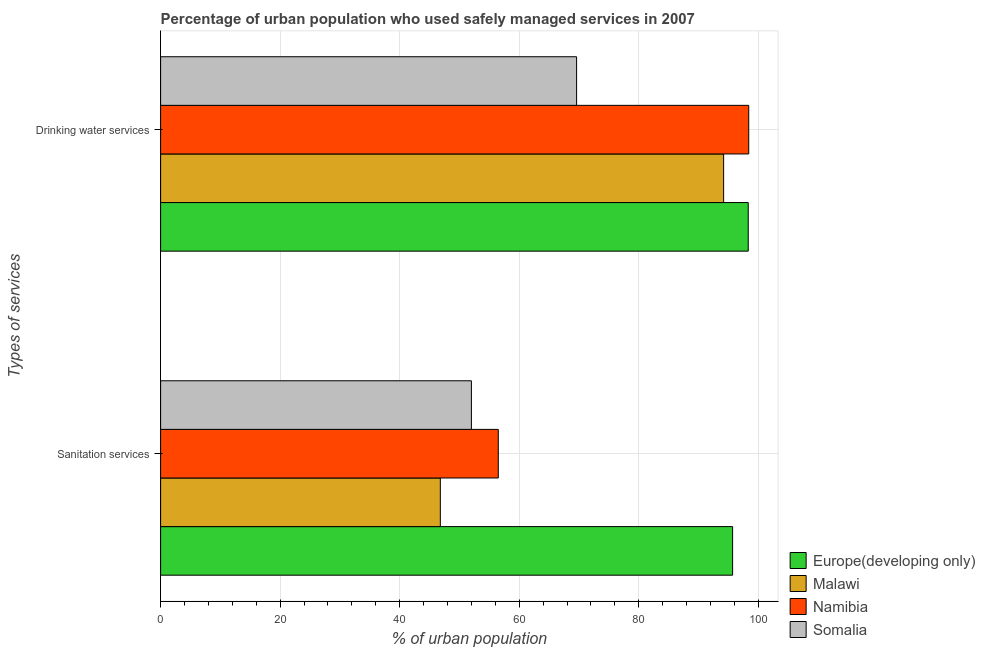How many different coloured bars are there?
Your answer should be compact. 4. How many groups of bars are there?
Offer a terse response. 2. Are the number of bars per tick equal to the number of legend labels?
Offer a very short reply. Yes. How many bars are there on the 2nd tick from the bottom?
Provide a short and direct response. 4. What is the label of the 2nd group of bars from the top?
Your answer should be compact. Sanitation services. What is the percentage of urban population who used drinking water services in Europe(developing only)?
Provide a succinct answer. 98.32. Across all countries, what is the maximum percentage of urban population who used sanitation services?
Ensure brevity in your answer.  95.7. Across all countries, what is the minimum percentage of urban population who used sanitation services?
Your answer should be very brief. 46.8. In which country was the percentage of urban population who used sanitation services maximum?
Give a very brief answer. Europe(developing only). In which country was the percentage of urban population who used drinking water services minimum?
Ensure brevity in your answer.  Somalia. What is the total percentage of urban population who used drinking water services in the graph?
Provide a short and direct response. 360.52. What is the difference between the percentage of urban population who used sanitation services in Namibia and that in Somalia?
Your answer should be very brief. 4.5. What is the difference between the percentage of urban population who used sanitation services in Europe(developing only) and the percentage of urban population who used drinking water services in Namibia?
Offer a very short reply. -2.7. What is the average percentage of urban population who used drinking water services per country?
Your response must be concise. 90.13. What is the difference between the percentage of urban population who used drinking water services and percentage of urban population who used sanitation services in Somalia?
Provide a succinct answer. 17.6. In how many countries, is the percentage of urban population who used drinking water services greater than 60 %?
Your answer should be very brief. 4. What is the ratio of the percentage of urban population who used drinking water services in Europe(developing only) to that in Somalia?
Keep it short and to the point. 1.41. In how many countries, is the percentage of urban population who used sanitation services greater than the average percentage of urban population who used sanitation services taken over all countries?
Provide a short and direct response. 1. What does the 3rd bar from the top in Drinking water services represents?
Provide a short and direct response. Malawi. What does the 1st bar from the bottom in Drinking water services represents?
Offer a very short reply. Europe(developing only). How many bars are there?
Provide a short and direct response. 8. Are the values on the major ticks of X-axis written in scientific E-notation?
Your answer should be very brief. No. How are the legend labels stacked?
Offer a very short reply. Vertical. What is the title of the graph?
Ensure brevity in your answer.  Percentage of urban population who used safely managed services in 2007. Does "Andorra" appear as one of the legend labels in the graph?
Offer a very short reply. No. What is the label or title of the X-axis?
Make the answer very short. % of urban population. What is the label or title of the Y-axis?
Provide a succinct answer. Types of services. What is the % of urban population in Europe(developing only) in Sanitation services?
Your response must be concise. 95.7. What is the % of urban population in Malawi in Sanitation services?
Offer a very short reply. 46.8. What is the % of urban population in Namibia in Sanitation services?
Provide a succinct answer. 56.5. What is the % of urban population in Europe(developing only) in Drinking water services?
Offer a very short reply. 98.32. What is the % of urban population of Malawi in Drinking water services?
Offer a terse response. 94.2. What is the % of urban population in Namibia in Drinking water services?
Provide a succinct answer. 98.4. What is the % of urban population in Somalia in Drinking water services?
Ensure brevity in your answer.  69.6. Across all Types of services, what is the maximum % of urban population of Europe(developing only)?
Provide a short and direct response. 98.32. Across all Types of services, what is the maximum % of urban population in Malawi?
Give a very brief answer. 94.2. Across all Types of services, what is the maximum % of urban population of Namibia?
Provide a succinct answer. 98.4. Across all Types of services, what is the maximum % of urban population in Somalia?
Offer a terse response. 69.6. Across all Types of services, what is the minimum % of urban population of Europe(developing only)?
Offer a very short reply. 95.7. Across all Types of services, what is the minimum % of urban population of Malawi?
Keep it short and to the point. 46.8. Across all Types of services, what is the minimum % of urban population of Namibia?
Your answer should be compact. 56.5. What is the total % of urban population of Europe(developing only) in the graph?
Give a very brief answer. 194.02. What is the total % of urban population of Malawi in the graph?
Make the answer very short. 141. What is the total % of urban population of Namibia in the graph?
Ensure brevity in your answer.  154.9. What is the total % of urban population of Somalia in the graph?
Keep it short and to the point. 121.6. What is the difference between the % of urban population in Europe(developing only) in Sanitation services and that in Drinking water services?
Your answer should be very brief. -2.61. What is the difference between the % of urban population in Malawi in Sanitation services and that in Drinking water services?
Your answer should be very brief. -47.4. What is the difference between the % of urban population of Namibia in Sanitation services and that in Drinking water services?
Your answer should be very brief. -41.9. What is the difference between the % of urban population in Somalia in Sanitation services and that in Drinking water services?
Provide a short and direct response. -17.6. What is the difference between the % of urban population of Europe(developing only) in Sanitation services and the % of urban population of Malawi in Drinking water services?
Provide a succinct answer. 1.5. What is the difference between the % of urban population of Europe(developing only) in Sanitation services and the % of urban population of Namibia in Drinking water services?
Ensure brevity in your answer.  -2.7. What is the difference between the % of urban population of Europe(developing only) in Sanitation services and the % of urban population of Somalia in Drinking water services?
Provide a succinct answer. 26.1. What is the difference between the % of urban population of Malawi in Sanitation services and the % of urban population of Namibia in Drinking water services?
Offer a terse response. -51.6. What is the difference between the % of urban population of Malawi in Sanitation services and the % of urban population of Somalia in Drinking water services?
Provide a succinct answer. -22.8. What is the average % of urban population of Europe(developing only) per Types of services?
Offer a very short reply. 97.01. What is the average % of urban population of Malawi per Types of services?
Provide a succinct answer. 70.5. What is the average % of urban population of Namibia per Types of services?
Give a very brief answer. 77.45. What is the average % of urban population in Somalia per Types of services?
Your answer should be very brief. 60.8. What is the difference between the % of urban population of Europe(developing only) and % of urban population of Malawi in Sanitation services?
Keep it short and to the point. 48.9. What is the difference between the % of urban population of Europe(developing only) and % of urban population of Namibia in Sanitation services?
Give a very brief answer. 39.2. What is the difference between the % of urban population of Europe(developing only) and % of urban population of Somalia in Sanitation services?
Provide a short and direct response. 43.7. What is the difference between the % of urban population in Namibia and % of urban population in Somalia in Sanitation services?
Offer a terse response. 4.5. What is the difference between the % of urban population in Europe(developing only) and % of urban population in Malawi in Drinking water services?
Your answer should be compact. 4.12. What is the difference between the % of urban population in Europe(developing only) and % of urban population in Namibia in Drinking water services?
Offer a very short reply. -0.08. What is the difference between the % of urban population in Europe(developing only) and % of urban population in Somalia in Drinking water services?
Ensure brevity in your answer.  28.72. What is the difference between the % of urban population in Malawi and % of urban population in Somalia in Drinking water services?
Ensure brevity in your answer.  24.6. What is the difference between the % of urban population of Namibia and % of urban population of Somalia in Drinking water services?
Provide a short and direct response. 28.8. What is the ratio of the % of urban population in Europe(developing only) in Sanitation services to that in Drinking water services?
Give a very brief answer. 0.97. What is the ratio of the % of urban population in Malawi in Sanitation services to that in Drinking water services?
Your answer should be very brief. 0.5. What is the ratio of the % of urban population of Namibia in Sanitation services to that in Drinking water services?
Ensure brevity in your answer.  0.57. What is the ratio of the % of urban population of Somalia in Sanitation services to that in Drinking water services?
Your answer should be compact. 0.75. What is the difference between the highest and the second highest % of urban population in Europe(developing only)?
Offer a terse response. 2.61. What is the difference between the highest and the second highest % of urban population in Malawi?
Your response must be concise. 47.4. What is the difference between the highest and the second highest % of urban population in Namibia?
Your answer should be compact. 41.9. What is the difference between the highest and the second highest % of urban population in Somalia?
Provide a succinct answer. 17.6. What is the difference between the highest and the lowest % of urban population in Europe(developing only)?
Make the answer very short. 2.61. What is the difference between the highest and the lowest % of urban population in Malawi?
Keep it short and to the point. 47.4. What is the difference between the highest and the lowest % of urban population in Namibia?
Your answer should be compact. 41.9. What is the difference between the highest and the lowest % of urban population in Somalia?
Make the answer very short. 17.6. 